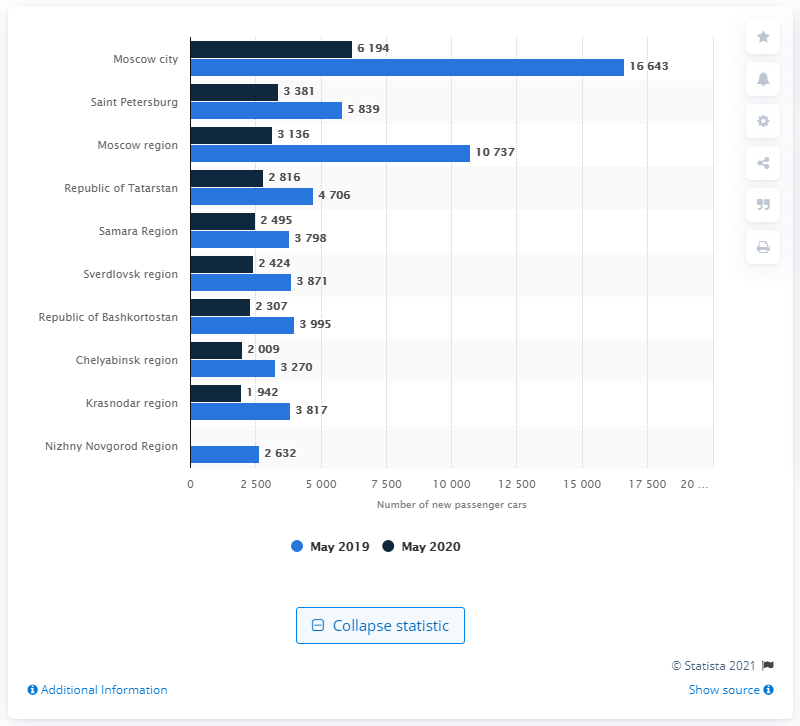Specify some key components in this picture. In May 2020, there were significantly fewer new cars registered in all areas compared to the same month of the previous year. 